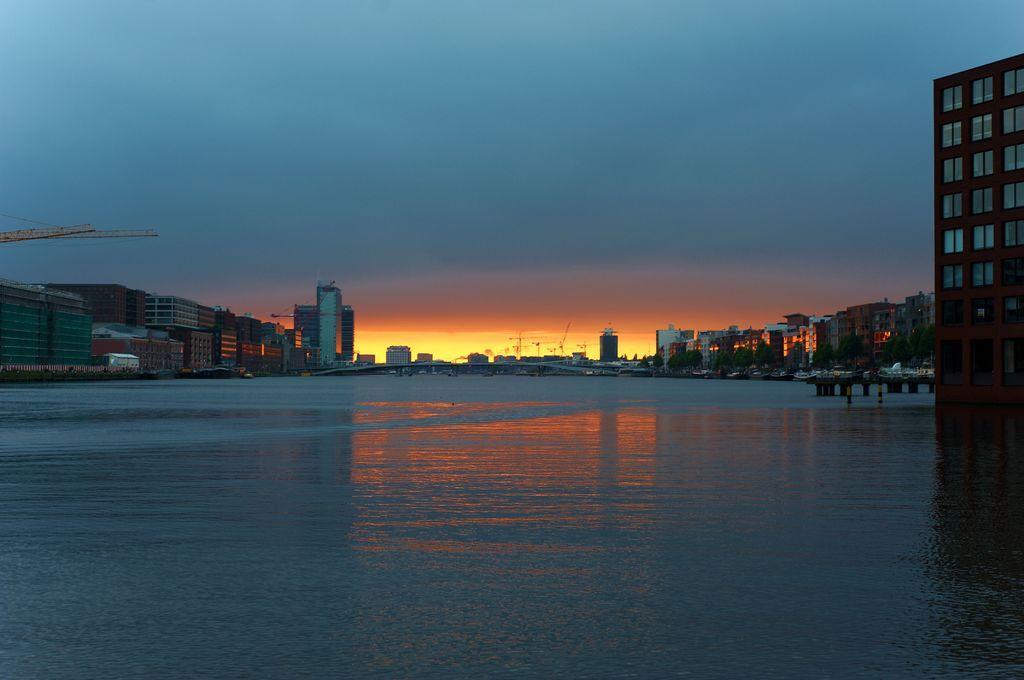How would you summarize this image in a sentence or two? In this image there are buildings. Right side there is a bridge. Bottom of the image there is water. Right side there are trees. Top of the image there is sky. Left side there is a crane. 